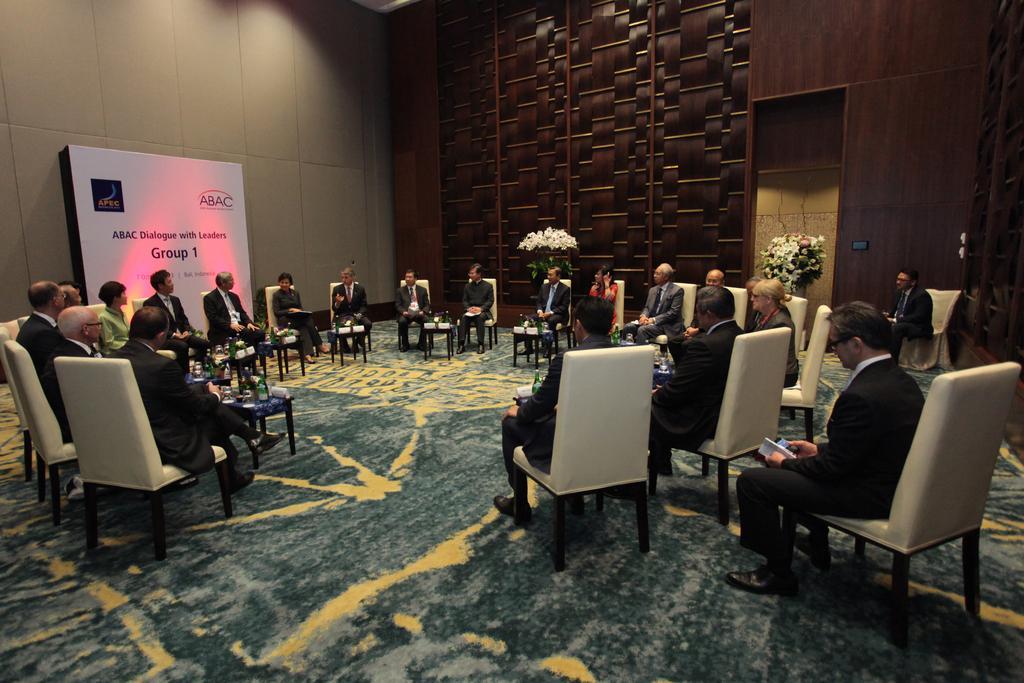Please provide a concise description of this image. In the image we can see there are people sitting on chair. This is a flower plant. This is a poster on which it is written group one. These people are wearing blazer. 